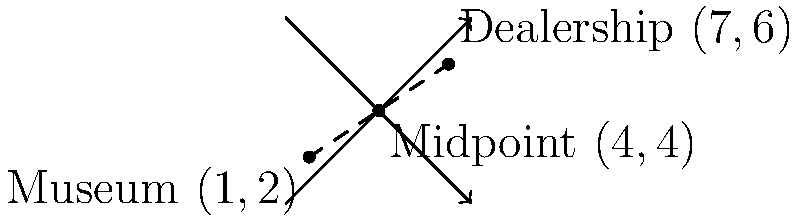As a car dealership owner supporting the local museum, you're planning a joint event. The museum is located at coordinates (1,2) and your dealership is at (7,6) on a city map. To find a suitable location for the event, you need to determine the midpoint between these two locations. Calculate the coordinates of this midpoint. To find the midpoint between two points, we use the midpoint formula:

$$ \text{Midpoint} = (\frac{x_1 + x_2}{2}, \frac{y_1 + y_2}{2}) $$

Where $(x_1, y_1)$ is the coordinate of the first point (museum) and $(x_2, y_2)$ is the coordinate of the second point (dealership).

1. Identify the coordinates:
   Museum: $(x_1, y_1) = (1, 2)$
   Dealership: $(x_2, y_2) = (7, 6)$

2. Calculate the x-coordinate of the midpoint:
   $$ x = \frac{x_1 + x_2}{2} = \frac{1 + 7}{2} = \frac{8}{2} = 4 $$

3. Calculate the y-coordinate of the midpoint:
   $$ y = \frac{y_1 + y_2}{2} = \frac{2 + 6}{2} = \frac{8}{2} = 4 $$

4. Combine the results:
   Midpoint = $(4, 4)$
Answer: $(4, 4)$ 